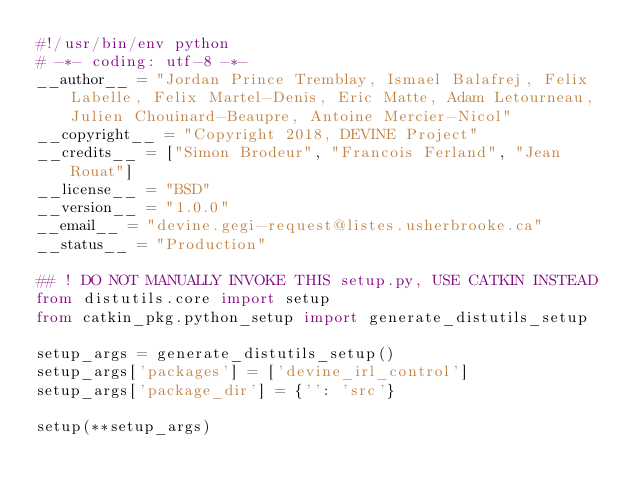<code> <loc_0><loc_0><loc_500><loc_500><_Python_>#!/usr/bin/env python
# -*- coding: utf-8 -*-
__author__ = "Jordan Prince Tremblay, Ismael Balafrej, Felix Labelle, Felix Martel-Denis, Eric Matte, Adam Letourneau, Julien Chouinard-Beaupre, Antoine Mercier-Nicol"
__copyright__ = "Copyright 2018, DEVINE Project"
__credits__ = ["Simon Brodeur", "Francois Ferland", "Jean Rouat"]
__license__ = "BSD"
__version__ = "1.0.0"
__email__ = "devine.gegi-request@listes.usherbrooke.ca"
__status__ = "Production"

## ! DO NOT MANUALLY INVOKE THIS setup.py, USE CATKIN INSTEAD
from distutils.core import setup
from catkin_pkg.python_setup import generate_distutils_setup

setup_args = generate_distutils_setup()
setup_args['packages'] = ['devine_irl_control']
setup_args['package_dir'] = {'': 'src'}

setup(**setup_args)
</code> 